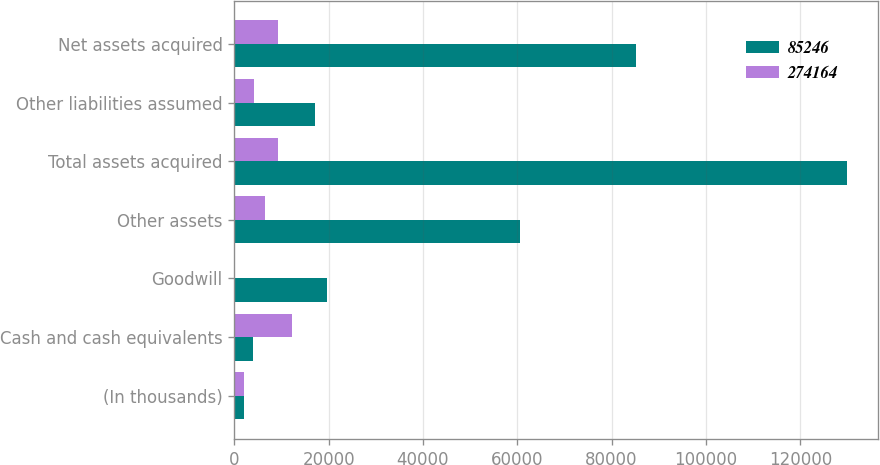Convert chart. <chart><loc_0><loc_0><loc_500><loc_500><stacked_bar_chart><ecel><fcel>(In thousands)<fcel>Cash and cash equivalents<fcel>Goodwill<fcel>Other assets<fcel>Total assets acquired<fcel>Other liabilities assumed<fcel>Net assets acquired<nl><fcel>85246<fcel>2013<fcel>3911<fcel>19664<fcel>60661<fcel>129934<fcel>17076<fcel>85246<nl><fcel>274164<fcel>2012<fcel>12172<fcel>251<fcel>6566<fcel>9369<fcel>4247<fcel>9369<nl></chart> 